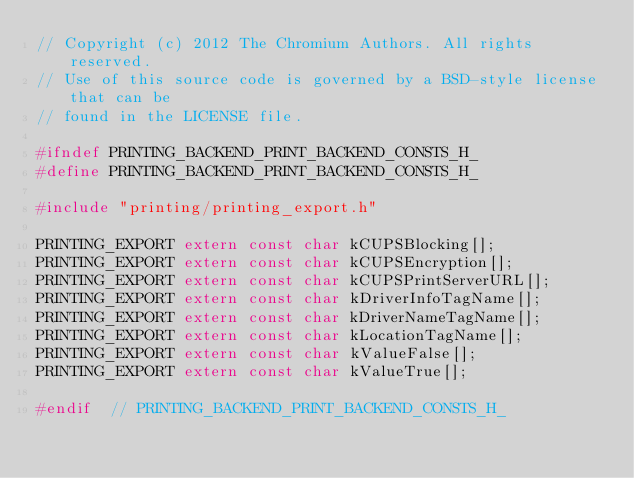Convert code to text. <code><loc_0><loc_0><loc_500><loc_500><_C_>// Copyright (c) 2012 The Chromium Authors. All rights reserved.
// Use of this source code is governed by a BSD-style license that can be
// found in the LICENSE file.

#ifndef PRINTING_BACKEND_PRINT_BACKEND_CONSTS_H_
#define PRINTING_BACKEND_PRINT_BACKEND_CONSTS_H_

#include "printing/printing_export.h"

PRINTING_EXPORT extern const char kCUPSBlocking[];
PRINTING_EXPORT extern const char kCUPSEncryption[];
PRINTING_EXPORT extern const char kCUPSPrintServerURL[];
PRINTING_EXPORT extern const char kDriverInfoTagName[];
PRINTING_EXPORT extern const char kDriverNameTagName[];
PRINTING_EXPORT extern const char kLocationTagName[];
PRINTING_EXPORT extern const char kValueFalse[];
PRINTING_EXPORT extern const char kValueTrue[];

#endif  // PRINTING_BACKEND_PRINT_BACKEND_CONSTS_H_
</code> 